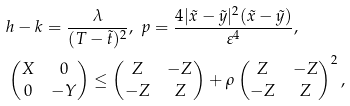Convert formula to latex. <formula><loc_0><loc_0><loc_500><loc_500>& h - k = \frac { \lambda } { ( T - \tilde { t } ) ^ { 2 } } , \ p = \frac { 4 | \tilde { x } - \tilde { y } | ^ { 2 } ( \tilde { x } - \tilde { y } ) } { \varepsilon ^ { 4 } } , \\ & \begin{pmatrix} X & 0 \\ 0 & - Y \end{pmatrix} \leq \begin{pmatrix} Z & - Z \\ - Z & Z \end{pmatrix} + \rho \begin{pmatrix} Z & - Z \\ - Z & Z \end{pmatrix} ^ { 2 } ,</formula> 